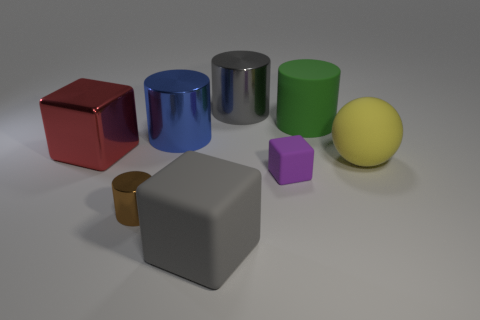Add 1 tiny purple metal cubes. How many objects exist? 9 Subtract all red cylinders. Subtract all brown balls. How many cylinders are left? 4 Subtract all spheres. How many objects are left? 7 Subtract all large green matte cylinders. Subtract all large red shiny blocks. How many objects are left? 6 Add 5 gray matte things. How many gray matte things are left? 6 Add 4 red shiny objects. How many red shiny objects exist? 5 Subtract 0 purple spheres. How many objects are left? 8 